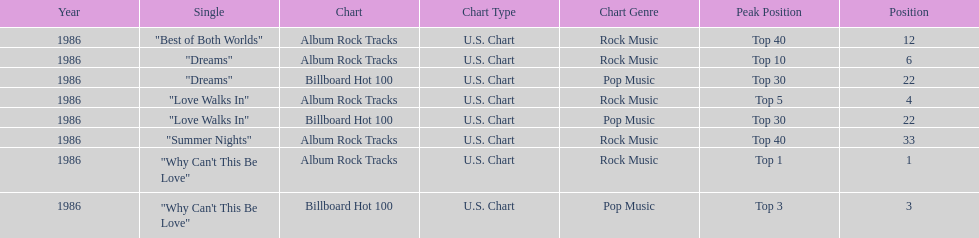Which singles each appear at position 22? Dreams, Love Walks In. 